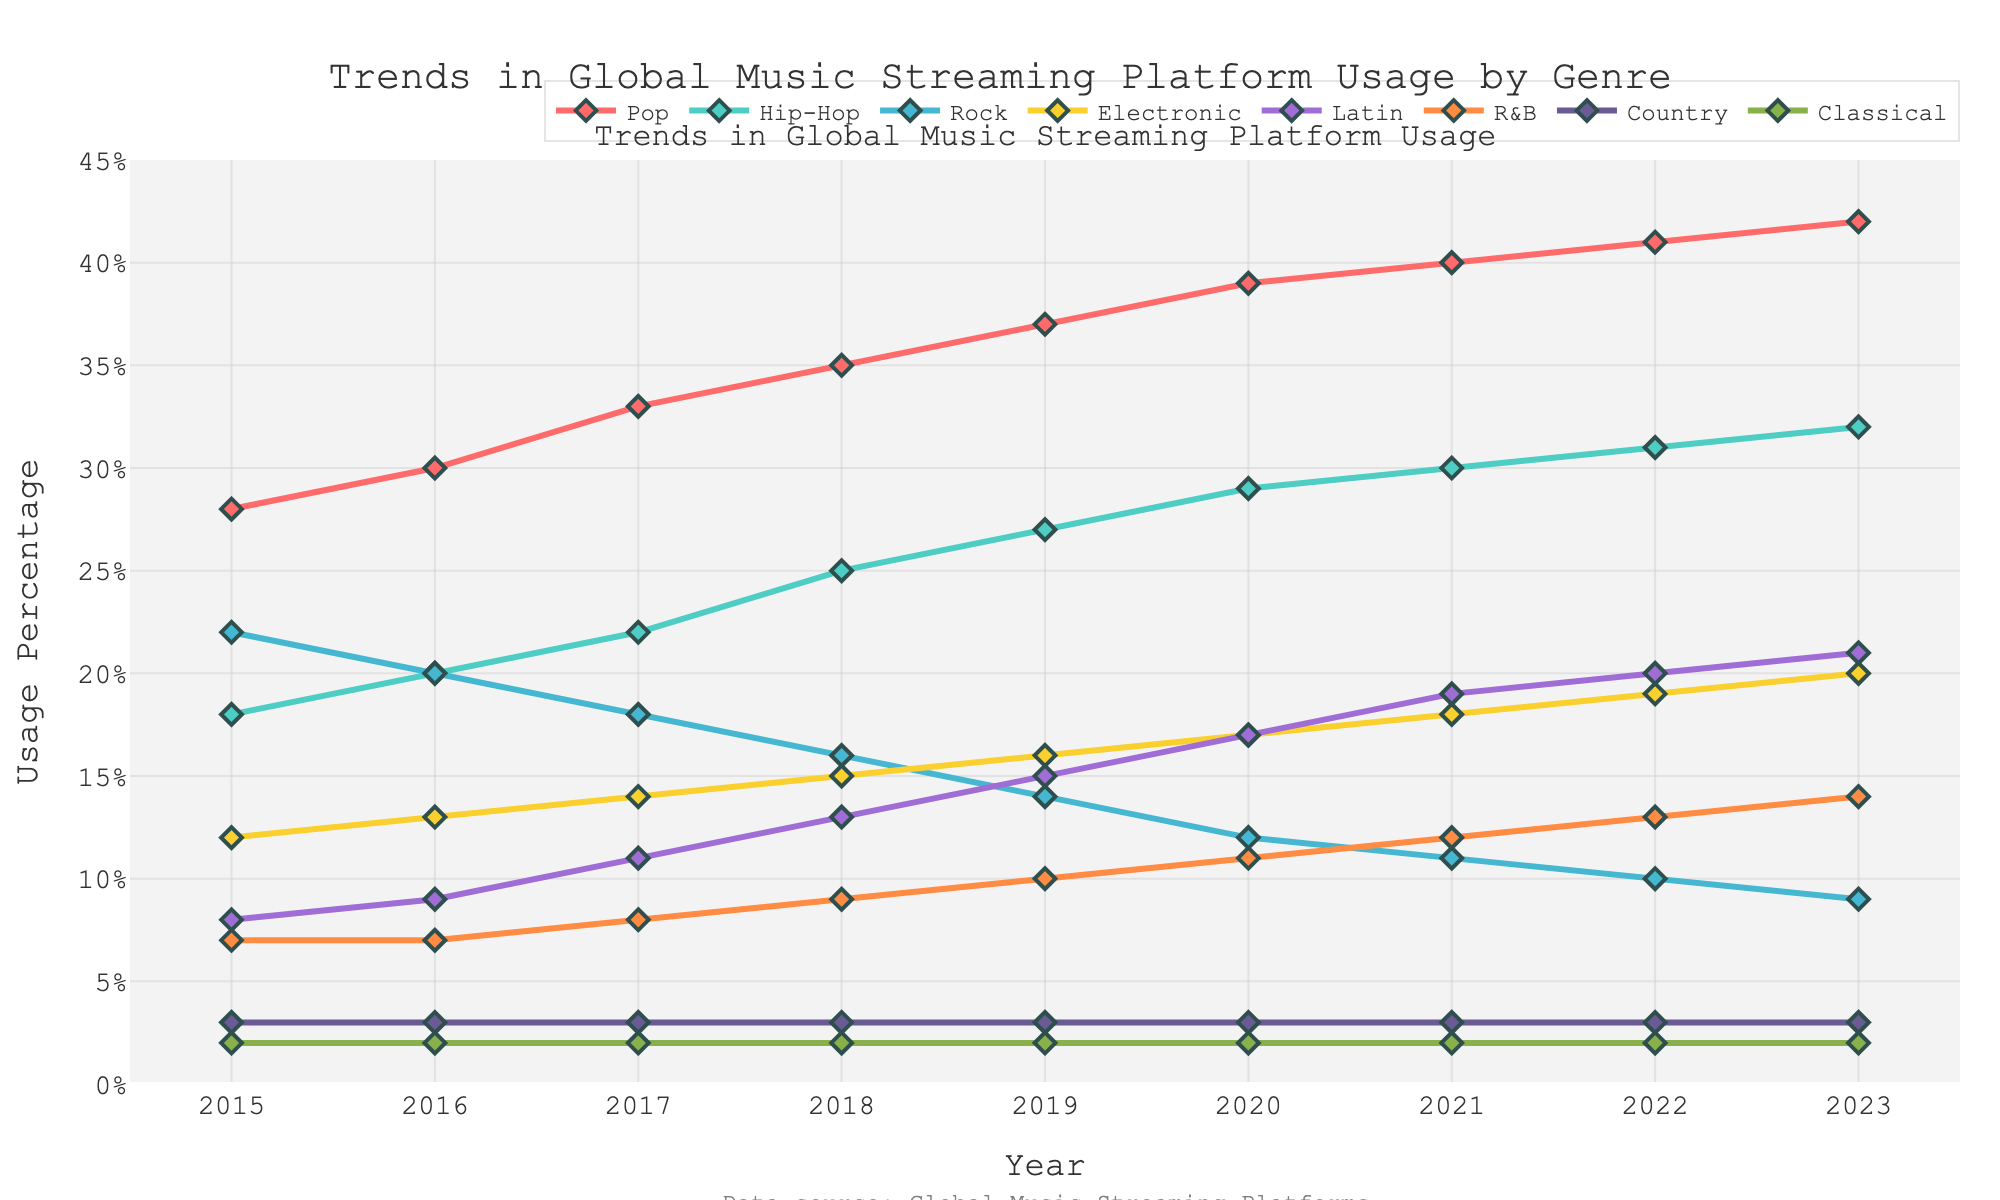How did the usage percentage of Pop change from 2015 to 2023? To determine the change in Pop usage percentage from 2015 to 2023, subtract the 2015 value (28%) from the 2023 value (42%). So, 42% - 28% = 14%.
Answer: 14% Which genre had the highest usage percentage in 2022? Look at the values for each genre in 2022 and compare them. Pop has the highest value at 41%.
Answer: Pop What is the combined usage percentage of Hip-Hop and Electronic in 2020? Add the values for Hip-Hop (29%) and Electronic (17%) in 2020. So, 29% + 17% = 46%.
Answer: 46% In which year did Rock have the highest usage percentage? Look at the values for Rock across all years and identify the highest value, which is 22% in 2015.
Answer: 2015 By how much did Latin's usage percentage increase from 2015 to 2023? Subtract the 2015 value (8%) from the 2023 value (21%). So, 21% - 8% = 13%.
Answer: 13% Which genre's usage remained constant over the years shown? Identify the genre with the same value in all years. Classical remains constant at 2% from 2015 to 2023.
Answer: Classical Compare the usage percentage of Pop and Rock in 2019. Which one is higher and by how much? Compare the values for 2019. Pop is 37% and Rock is 14%. Pop is higher by 37% - 14% = 23%.
Answer: Pop, by 23% How many genres have a usage percentage greater than or equal to 30% in 2023? Check the 2023 values for each genre and count those that are 30% or more: Pop (42%), Hip-Hop (32%), and Electronic (30%). There are three such genres.
Answer: 3 What is the trend in the usage percentage of R&B from 2015 to 2023? Observe the R&B values. They increase from 7% in 2015 to 14% in 2023. So, the trend is an upward increase.
Answer: Increasing What is the average usage percentage of Country from 2015 to 2023? Sum the values of Country for each year (3+3+3+3+3+3+3+3+3=27) and divide by the number of years (9). So, 27/9 = 3%.
Answer: 3% 